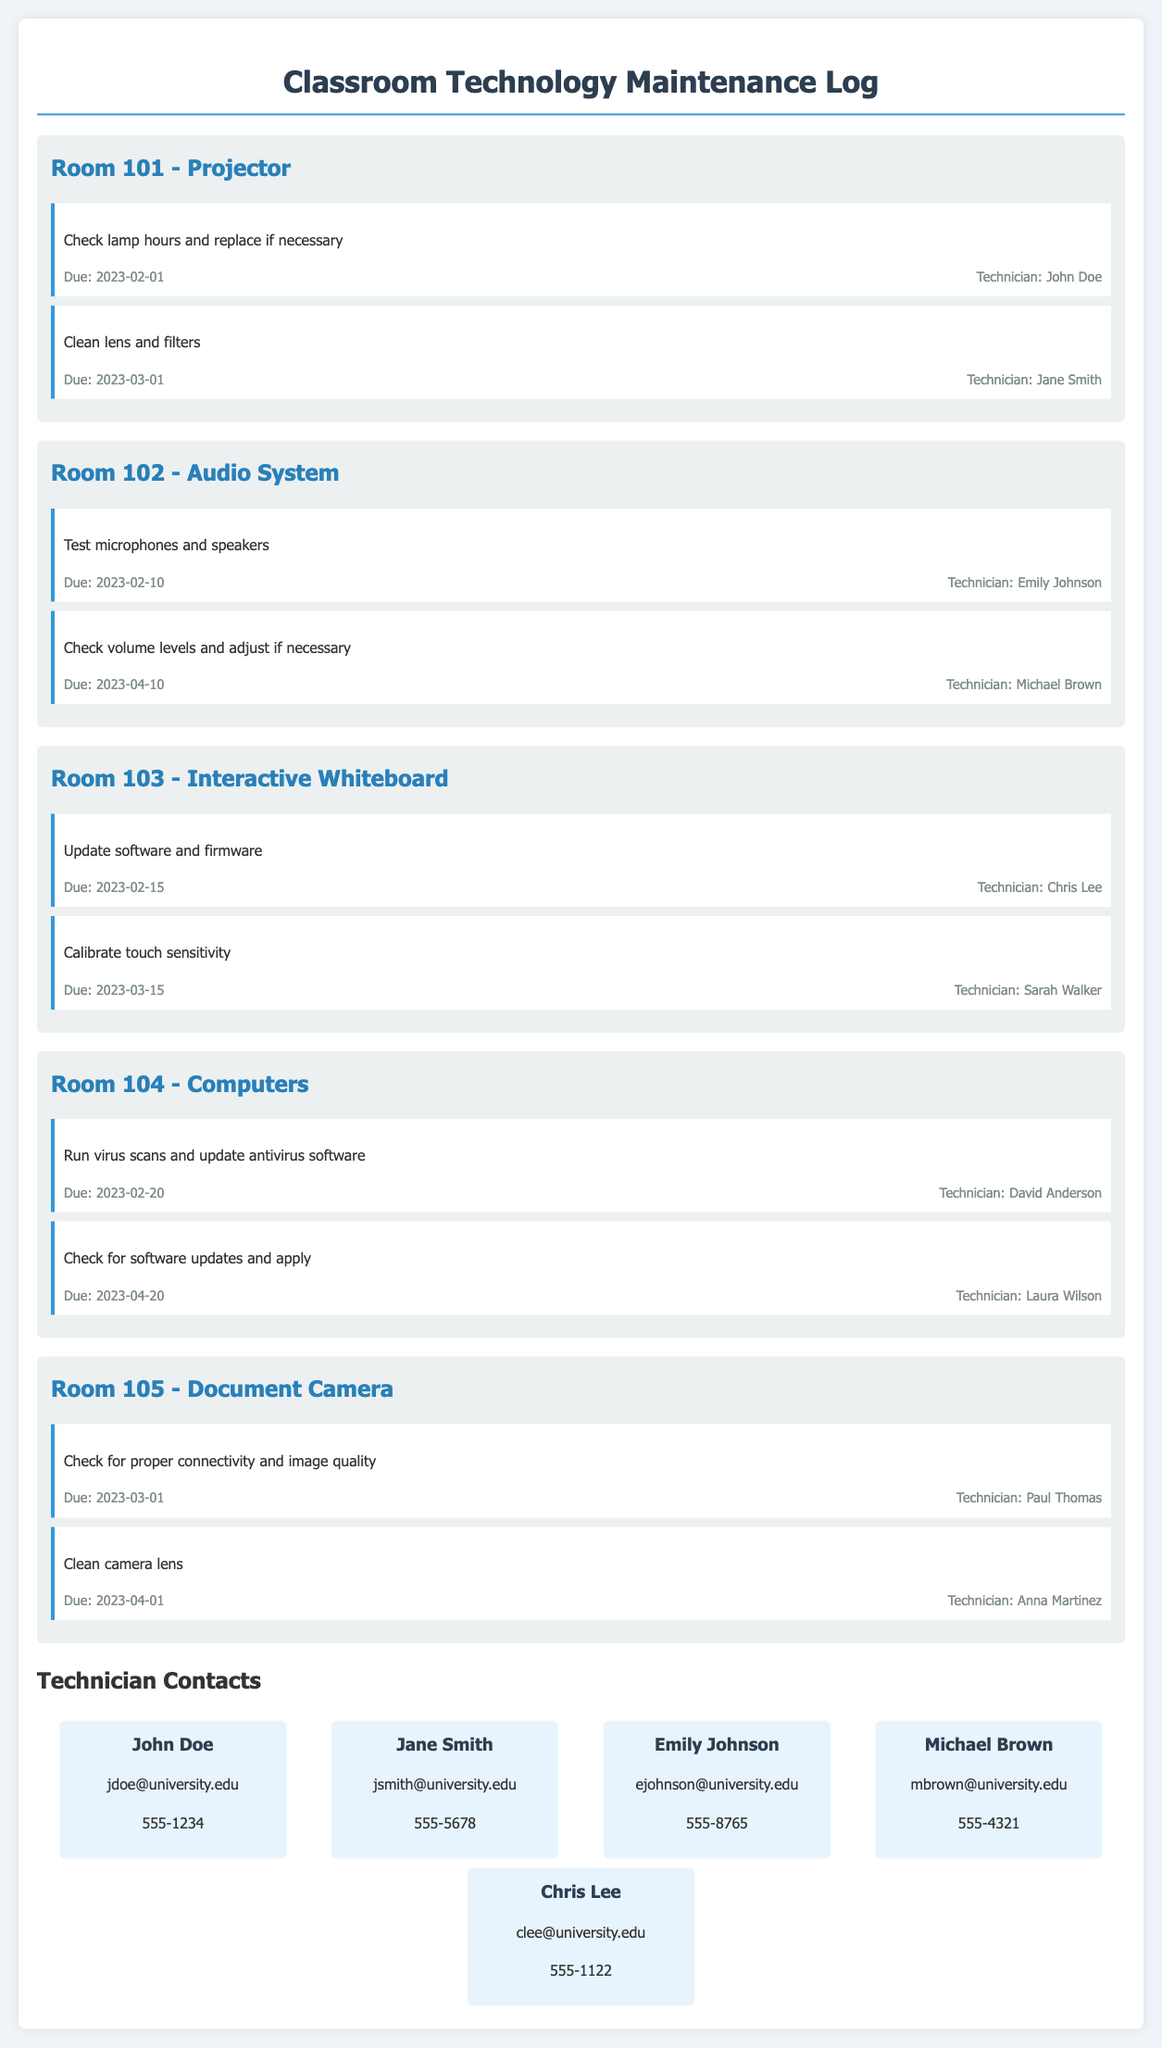What task is due on February 1, 2023? The task due on this date for Room 101 is to check lamp hours and replace if necessary.
Answer: Check lamp hours and replace if necessary Who is assigned to clean the lens and filters in Room 101? The technician assigned to this task is listed as Jane Smith.
Answer: Jane Smith What is the due date for testing microphones and speakers in Room 102? The document specifies that this task is due on February 10, 2023.
Answer: February 10, 2023 Which technician is responsible for calibrating touch sensitivity in Room 103? The task is assigned to Sarah Walker according to the document.
Answer: Sarah Walker What maintenance task is scheduled for April 10, 2023, in Room 102? This task is to check volume levels and adjust if necessary.
Answer: Check volume levels and adjust if necessary How many tasks are scheduled for Room 104? The document shows two tasks scheduled for Room 104.
Answer: Two tasks Which room has a document camera? Room 105 contains the document camera according to the document.
Answer: Room 105 What is the contact email for Chris Lee? The email address for Chris Lee listed in the contacts is clee@university.edu.
Answer: clee@university.edu When is the last task due for Room 105? The last task due for Room 105 is on April 1, 2023, which involves cleaning the camera lens.
Answer: April 1, 2023 